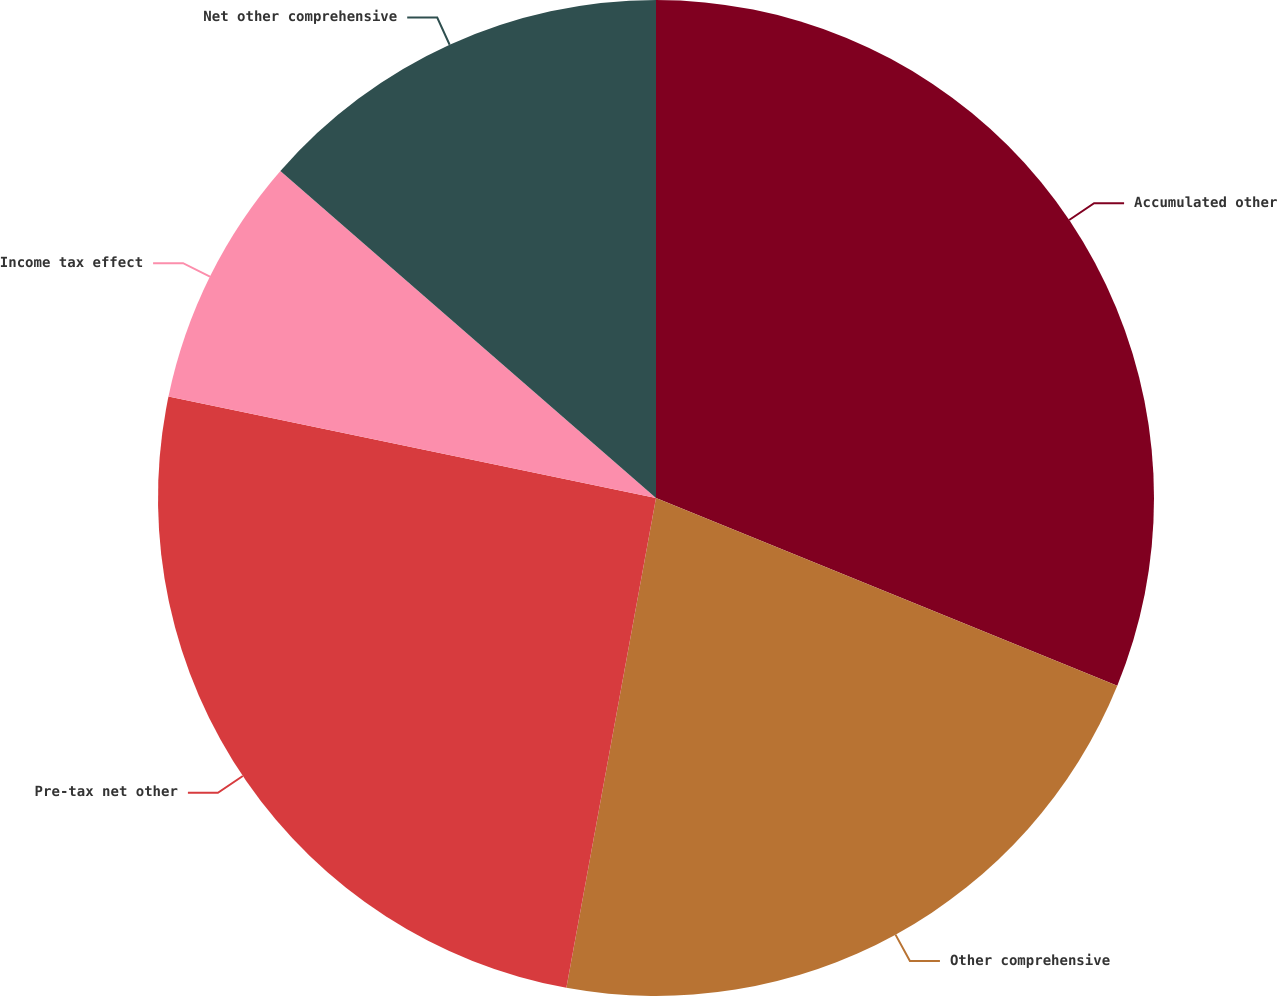Convert chart. <chart><loc_0><loc_0><loc_500><loc_500><pie_chart><fcel>Accumulated other<fcel>Other comprehensive<fcel>Pre-tax net other<fcel>Income tax effect<fcel>Net other comprehensive<nl><fcel>31.15%<fcel>21.73%<fcel>25.39%<fcel>8.13%<fcel>13.6%<nl></chart> 